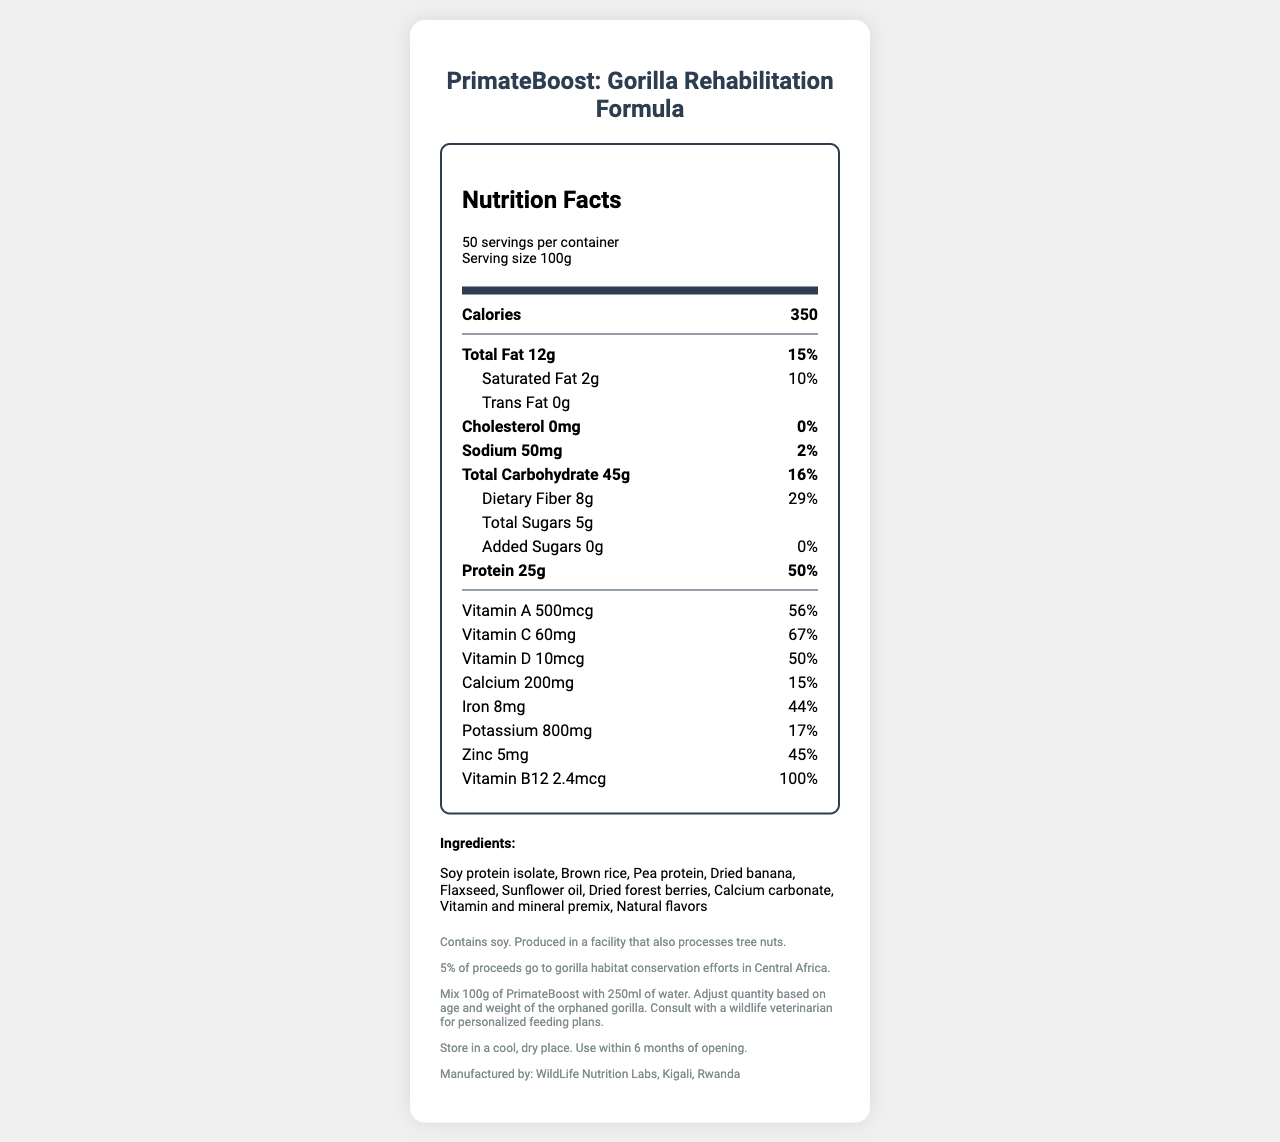what is the name of the product? The product name is clearly stated at the top of the document.
Answer: PrimateBoost: Gorilla Rehabilitation Formula what is the serving size? The serving size is specified as "100g" in the serving information section of the document.
Answer: 100g how many calories are there per serving? The number of calories per serving is listed as 350 in the nutrition facts section.
Answer: 350 name two primary protein sources in the ingredients list. The ingredients list includes "Soy protein isolate" and "Pea protein" as two primary protein sources.
Answer: Soy protein isolate, Pea protein what is the serving suggestion for orphaned gorillas? The feeding instructions section states to mix 100g of PrimateBoost with 250ml of water.
Answer: Mix 100g of PrimateBoost with 250ml of water. how much dietary fiber does each serving contain? The nutrition facts section specifies that each serving contains 8g of dietary fiber.
Answer: 8g how long can you store the product after opening? The storage instructions indicate that the product should be used within 6 months of opening.
Answer: 6 months which facility manufactures the product? The manufacturer listed is WildLife Nutrition Labs, located in Kigali, Rwanda.
Answer: WildLife Nutrition Labs, Kigali, Rwanda what percentage of proceeds go to conservation efforts? The conservation note mentions that 5% of proceeds go to gorilla habitat conservation efforts in Central Africa.
Answer: 5% does this product contain any cholesterol? The nutrition label states that it contains 0mg of cholesterol, which translates to 0% of the daily value.
Answer: No which age group is the product intended for? A. Newborns B. Juvenile Gorillas C. Orphaned Gorillas The document specifies that the product is designed for rehabilitating orphaned gorillas.
Answer: C what is the main purpose of this food pellet? A. Weight gain B. Rehabilitation C. Disease prevention The name and various parts of the document clearly indicate that the primary purpose is rehabilitation, specifically for orphaned gorillas.
Answer: B is this product free of added sugars? Y/N The nutrition label states that there are 0g of added sugars, indicating that the product is free of added sugars.
Answer: Yes summarize the purpose and nutritional aspects of the document. The document aims to inform about the nutritional benefits and feeding guidelines of a product specifically designed for orphaned gorillas, emphasizing its nutrient-rich composition and conservation efforts.
Answer: The document provides detailed nutritional information about "PrimateBoost: Gorilla Rehabilitation Formula", a specialized food pellet designed for rehabilitating orphaned gorillas. It lists the ingredients, storage instructions, feeding instructions, and informs that 5% of the proceeds go to conservation efforts. The nutrition label highlights that each 100g serving contains 350 calories, 25g of protein, 45g of carbohydrates, and various key vitamins and minerals. what is the production date of PrimateBoost? The document does not provide any information regarding the production date of PrimateBoost.
Answer: Not enough information 